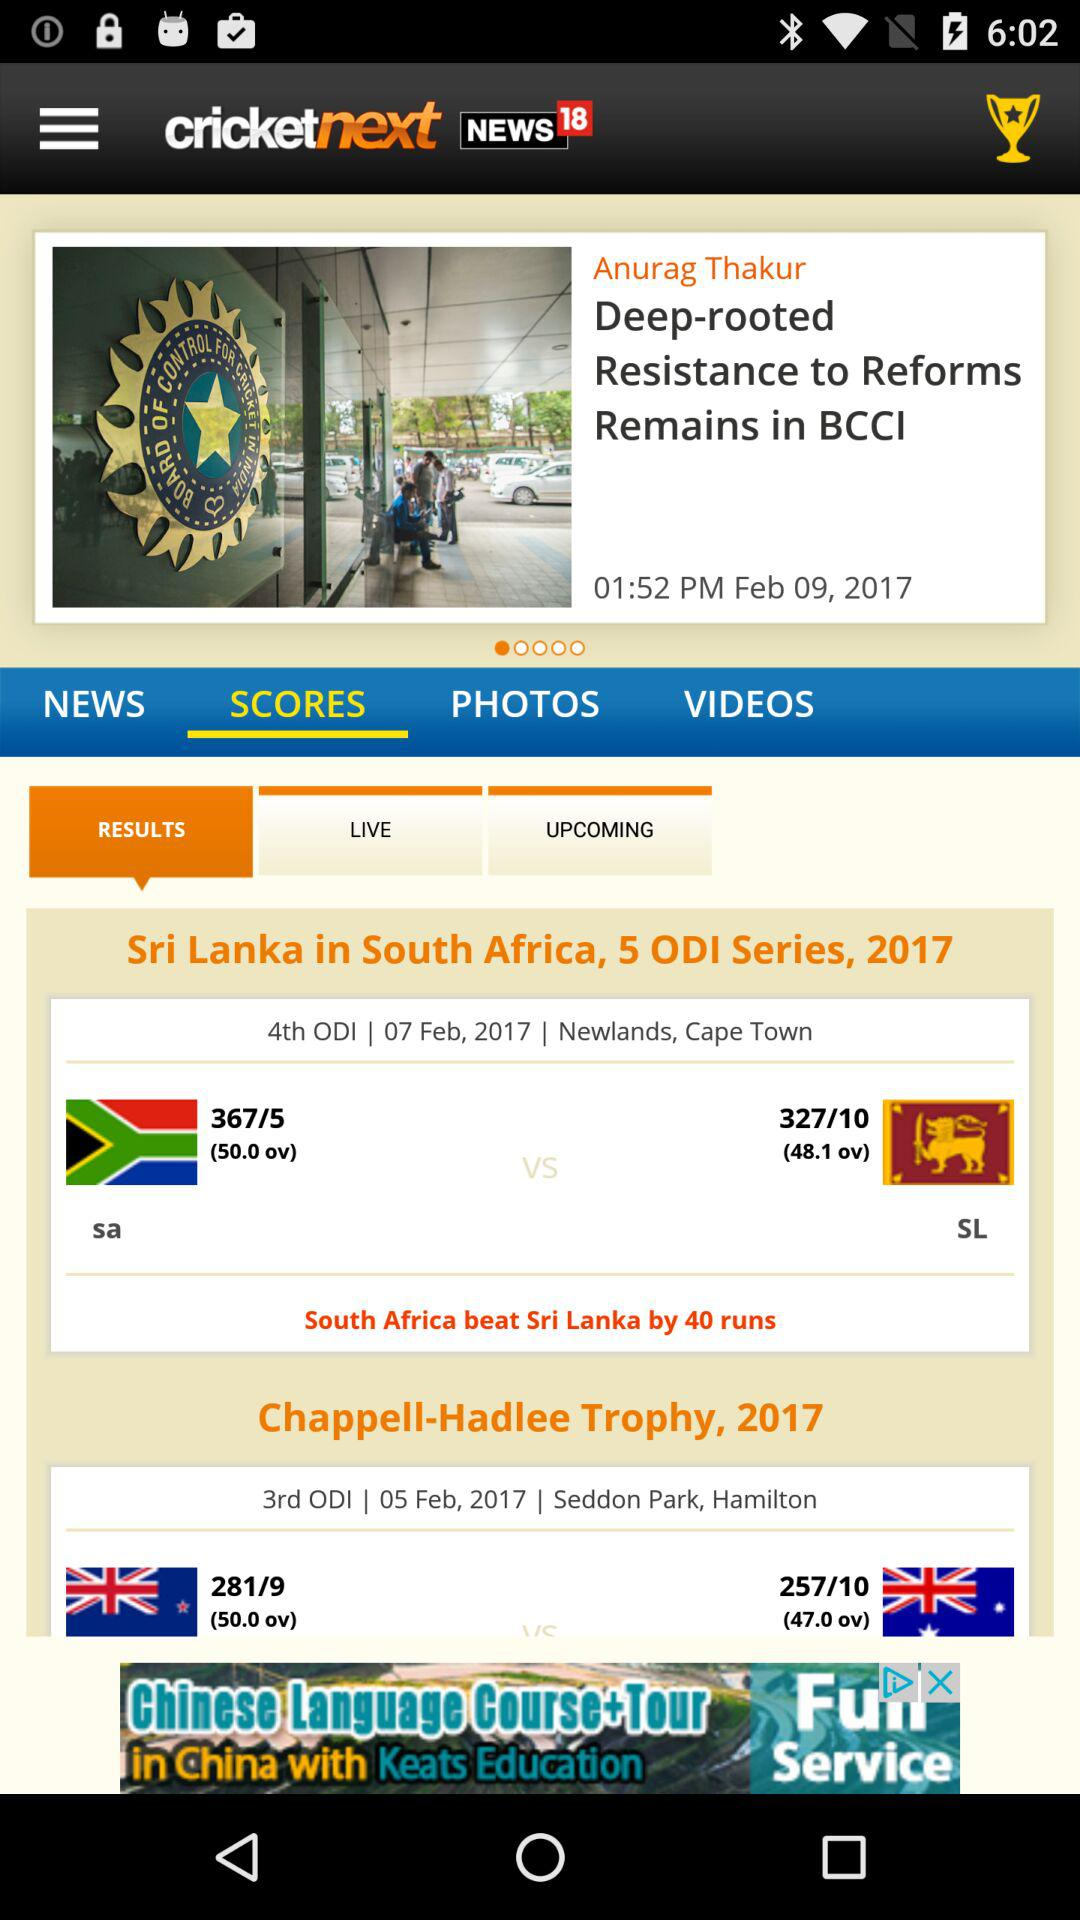What was the result of the "Sri Lanka" vs. "South Africa" match? The result of the match is that "South Africa" beat "Sri Lanka" by 40 runs. 